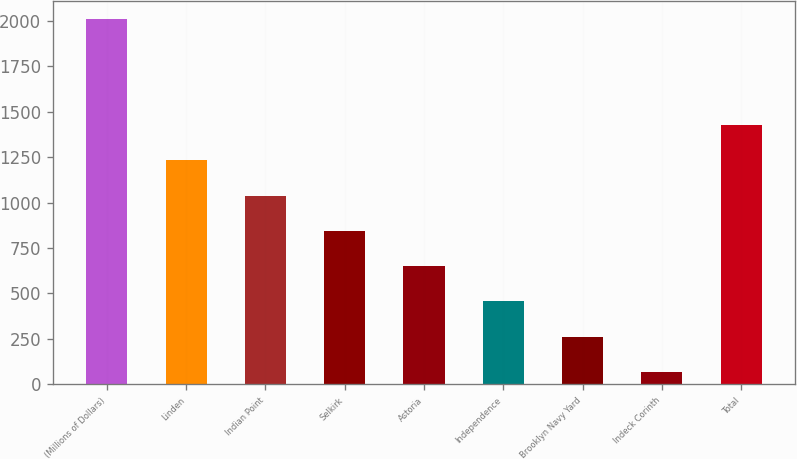Convert chart. <chart><loc_0><loc_0><loc_500><loc_500><bar_chart><fcel>(Millions of Dollars)<fcel>Linden<fcel>Indian Point<fcel>Selkirk<fcel>Astoria<fcel>Independence<fcel>Brooklyn Navy Yard<fcel>Indeck Corinth<fcel>Total<nl><fcel>2012<fcel>1233.6<fcel>1039<fcel>844.4<fcel>649.8<fcel>455.2<fcel>260.6<fcel>66<fcel>1428.2<nl></chart> 